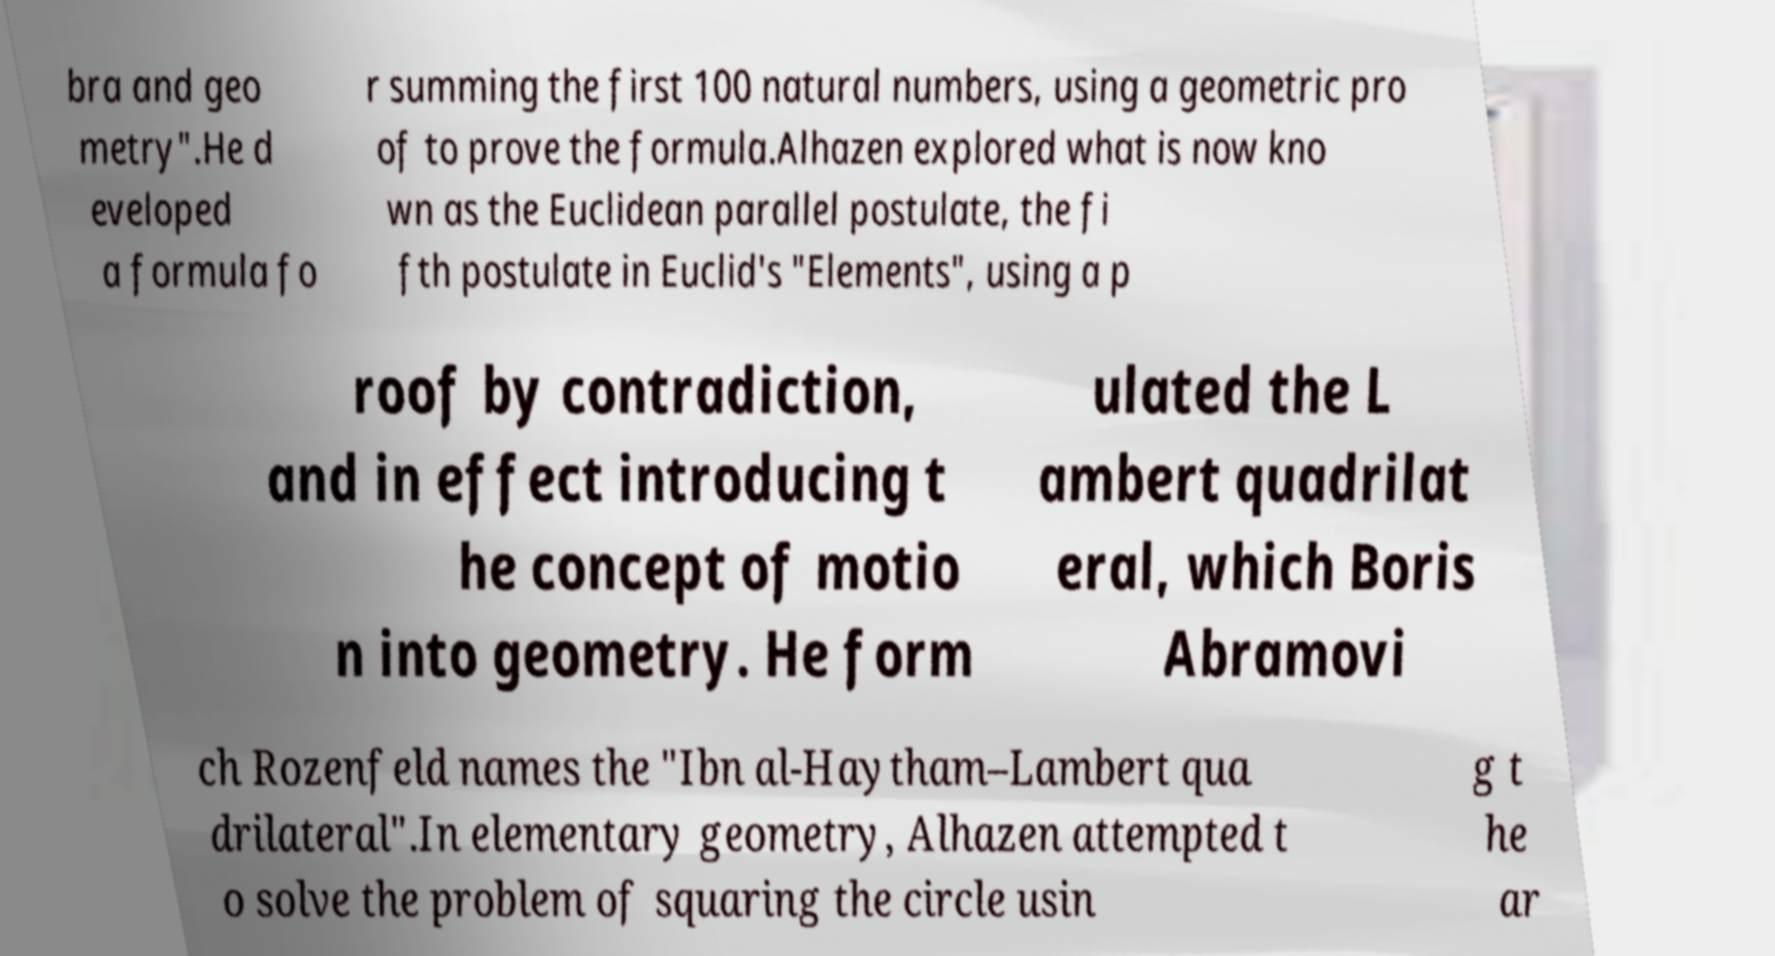Could you assist in decoding the text presented in this image and type it out clearly? bra and geo metry".He d eveloped a formula fo r summing the first 100 natural numbers, using a geometric pro of to prove the formula.Alhazen explored what is now kno wn as the Euclidean parallel postulate, the fi fth postulate in Euclid's "Elements", using a p roof by contradiction, and in effect introducing t he concept of motio n into geometry. He form ulated the L ambert quadrilat eral, which Boris Abramovi ch Rozenfeld names the "Ibn al-Haytham–Lambert qua drilateral".In elementary geometry, Alhazen attempted t o solve the problem of squaring the circle usin g t he ar 